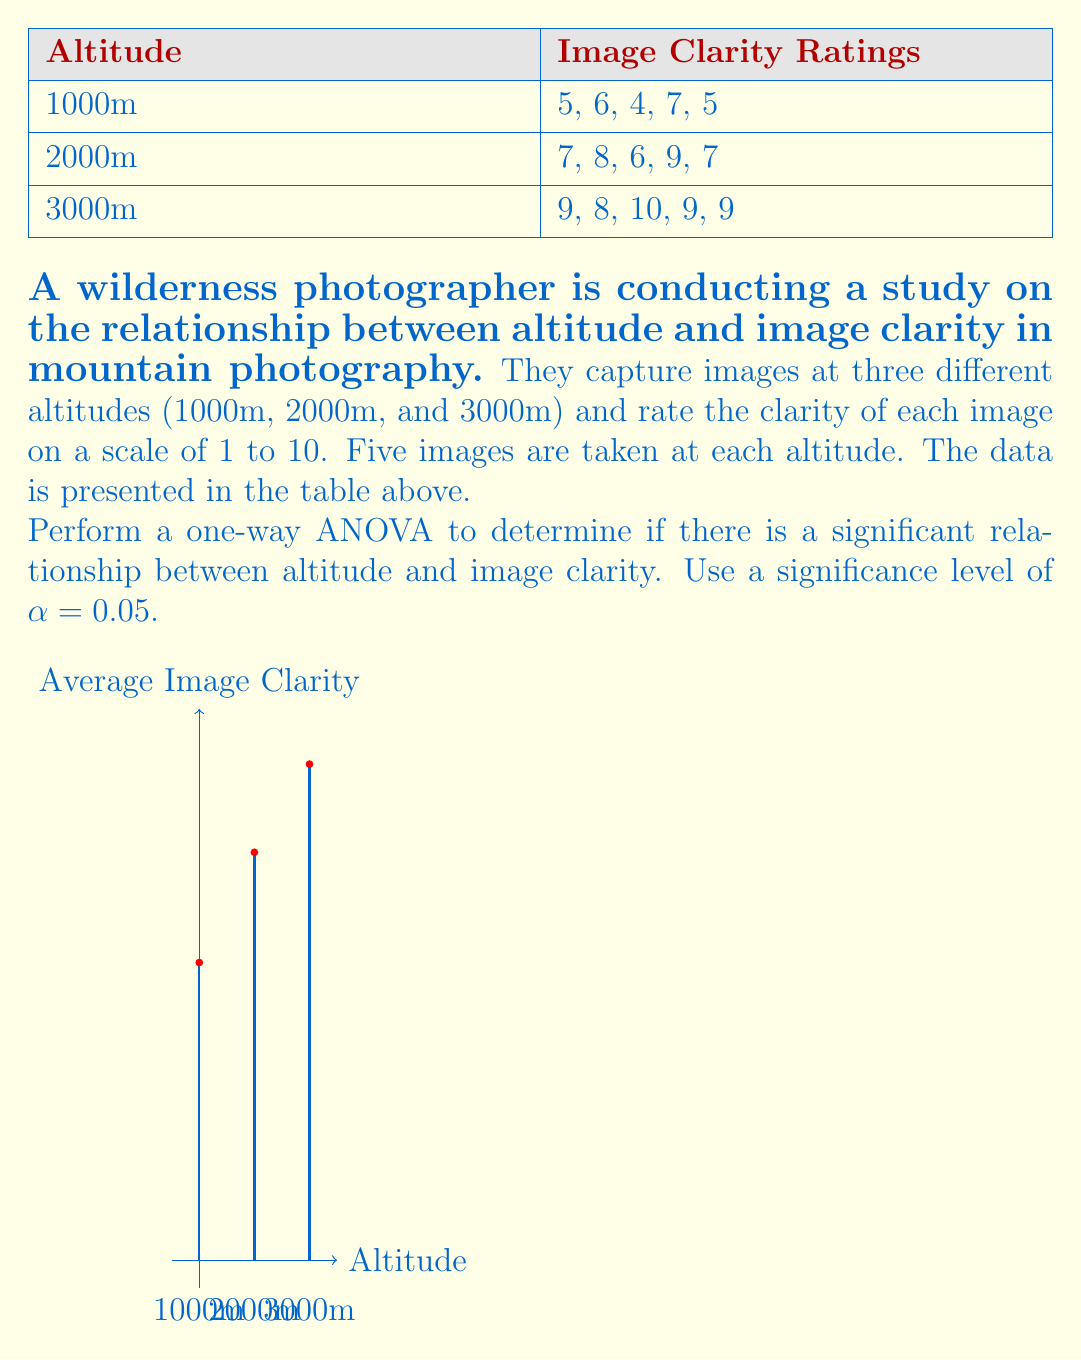Could you help me with this problem? To perform a one-way ANOVA, we'll follow these steps:

1. Calculate the mean for each group and the grand mean:
   1000m mean: $\bar{x}_1 = \frac{5+6+4+7+5}{5} = 5.4$
   2000m mean: $\bar{x}_2 = \frac{7+8+6+9+7}{5} = 7.4$
   3000m mean: $\bar{x}_3 = \frac{9+8+10+9+9}{5} = 9$
   Grand mean: $\bar{x} = \frac{5.4+7.4+9}{3} = 7.267$

2. Calculate the Sum of Squares Between groups (SSB):
   $$SSB = \sum_{i=1}^k n_i(\bar{x}_i - \bar{x})^2$$
   $$SSB = 5(5.4-7.267)^2 + 5(7.4-7.267)^2 + 5(9-7.267)^2 = 40.133$$

3. Calculate the Sum of Squares Within groups (SSW):
   $$SSW = \sum_{i=1}^k \sum_{j=1}^{n_i} (x_{ij} - \bar{x}_i)^2$$
   $$SSW = [(5-5.4)^2 + (6-5.4)^2 + (4-5.4)^2 + (7-5.4)^2 + (5-5.4)^2] +$$
   $$[(7-7.4)^2 + (8-7.4)^2 + (6-7.4)^2 + (9-7.4)^2 + (7-7.4)^2] +$$
   $$[(9-9)^2 + (8-9)^2 + (10-9)^2 + (9-9)^2 + (9-9)^2] = 14.8$$

4. Calculate the degrees of freedom:
   Between groups: $df_B = k - 1 = 3 - 1 = 2$
   Within groups: $df_W = N - k = 15 - 3 = 12$

5. Calculate the Mean Square Between (MSB) and Mean Square Within (MSW):
   $$MSB = \frac{SSB}{df_B} = \frac{40.133}{2} = 20.067$$
   $$MSW = \frac{SSW}{df_W} = \frac{14.8}{12} = 1.233$$

6. Calculate the F-statistic:
   $$F = \frac{MSB}{MSW} = \frac{20.067}{1.233} = 16.273$$

7. Find the critical F-value:
   For $α = 0.05$, $df_B = 2$, and $df_W = 12$, the critical F-value is approximately 3.89.

8. Compare the F-statistic to the critical F-value:
   Since $16.273 > 3.89$, we reject the null hypothesis.
Answer: F(2,12) = 16.273, p < 0.05. Significant relationship between altitude and image clarity. 